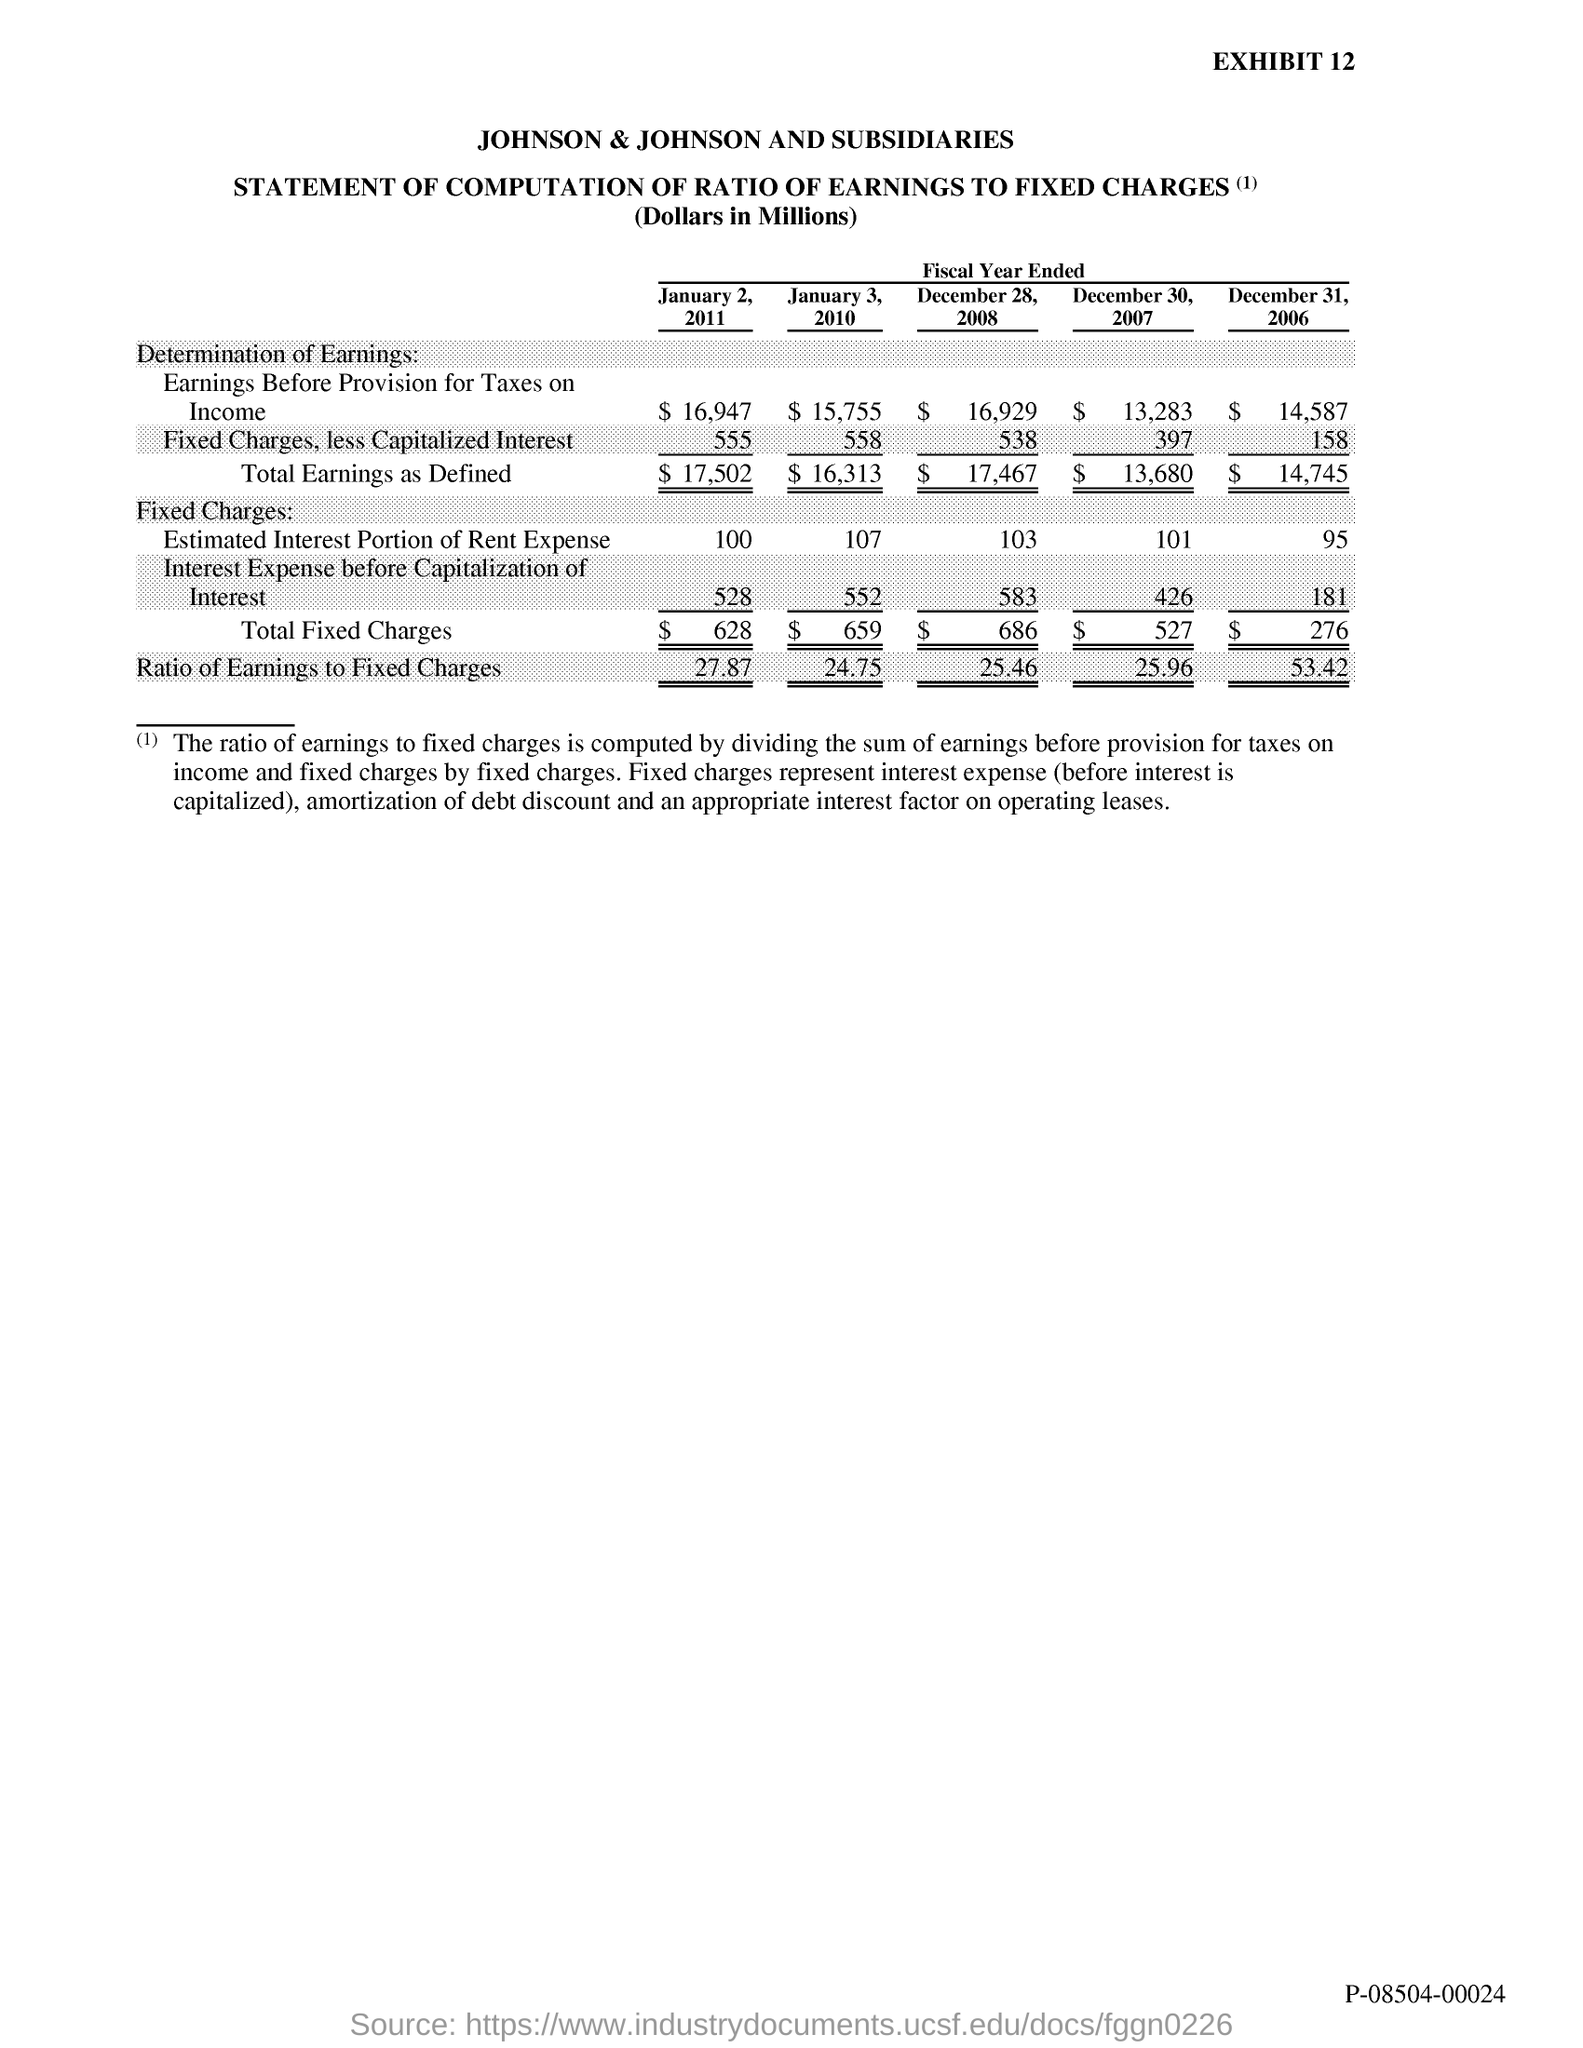List a handful of essential elements in this visual. The document's first title is 'Johnson & Johnson and Subsidiaries.' The exhibit number is 12. 